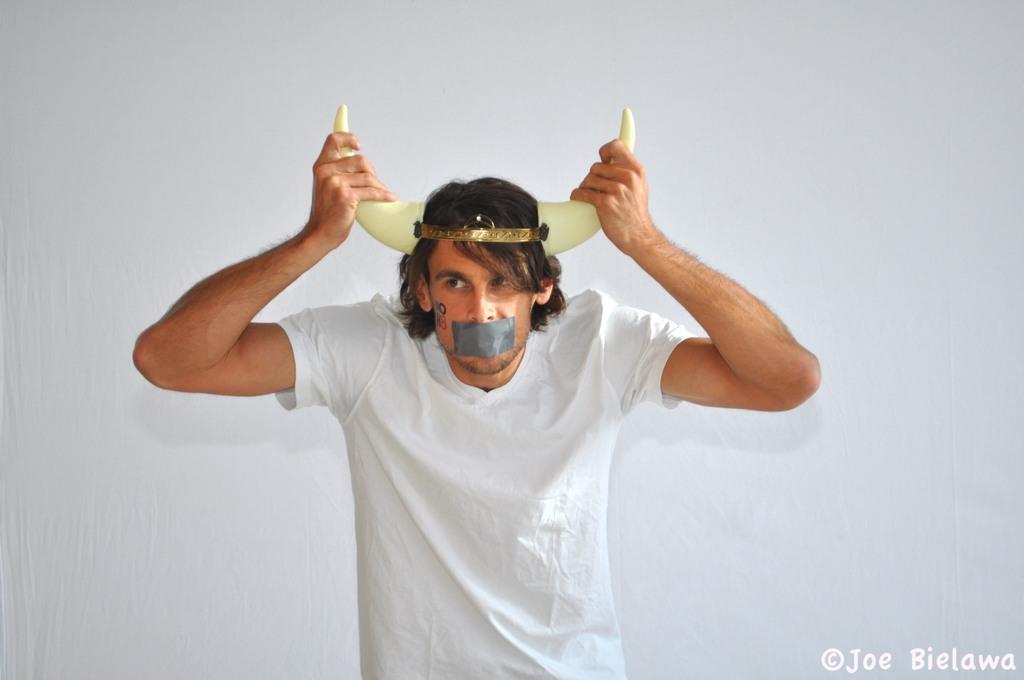Please provide a concise description of this image. In this image we can see a man is standing, he is wearing the white t-shirt, and there is a tape on the mouth, on the top there are horns, the background is in white color. 